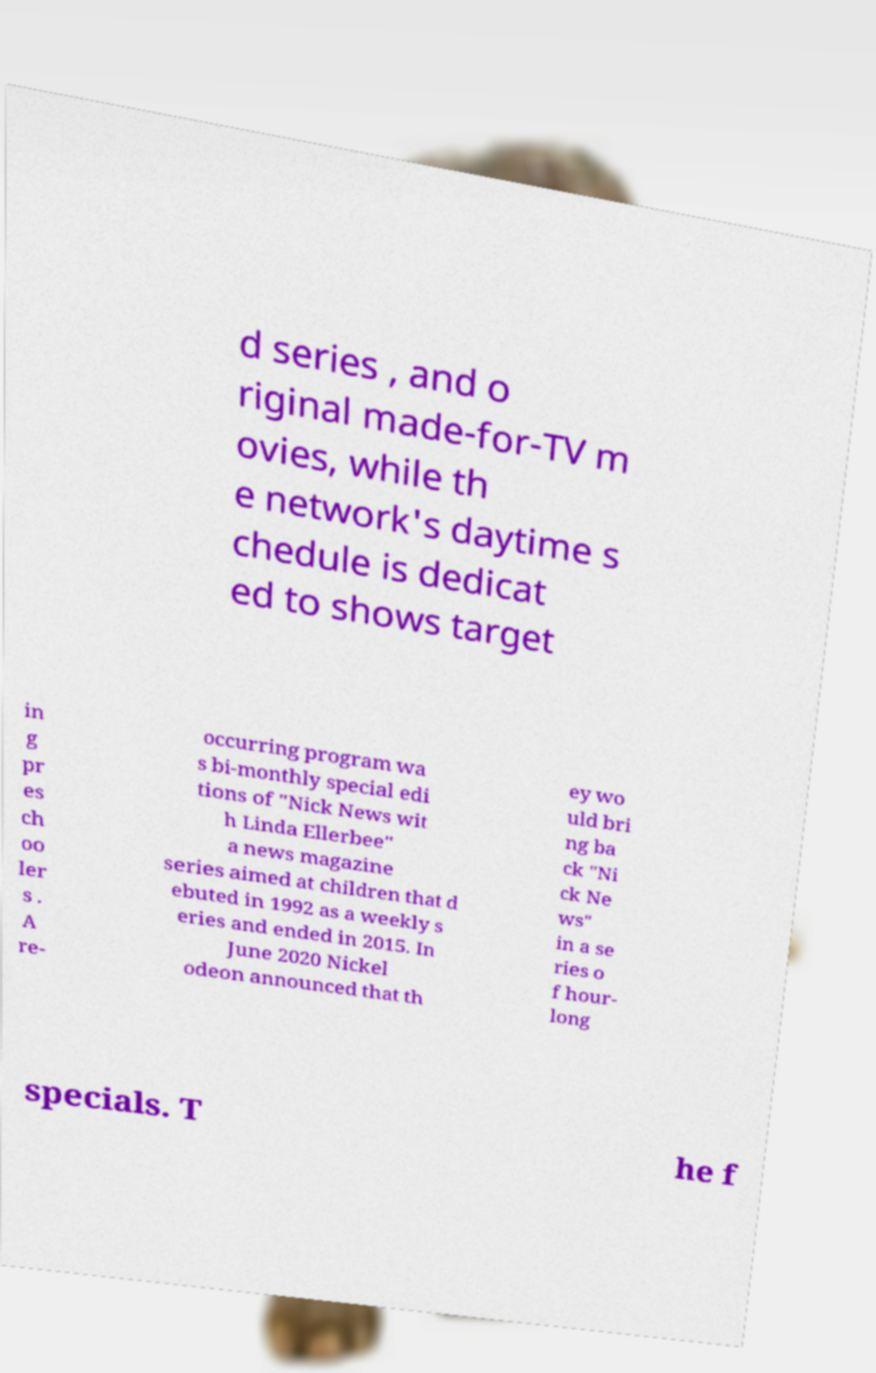There's text embedded in this image that I need extracted. Can you transcribe it verbatim? d series , and o riginal made-for-TV m ovies, while th e network's daytime s chedule is dedicat ed to shows target in g pr es ch oo ler s . A re- occurring program wa s bi-monthly special edi tions of "Nick News wit h Linda Ellerbee" a news magazine series aimed at children that d ebuted in 1992 as a weekly s eries and ended in 2015. In June 2020 Nickel odeon announced that th ey wo uld bri ng ba ck "Ni ck Ne ws" in a se ries o f hour- long specials. T he f 